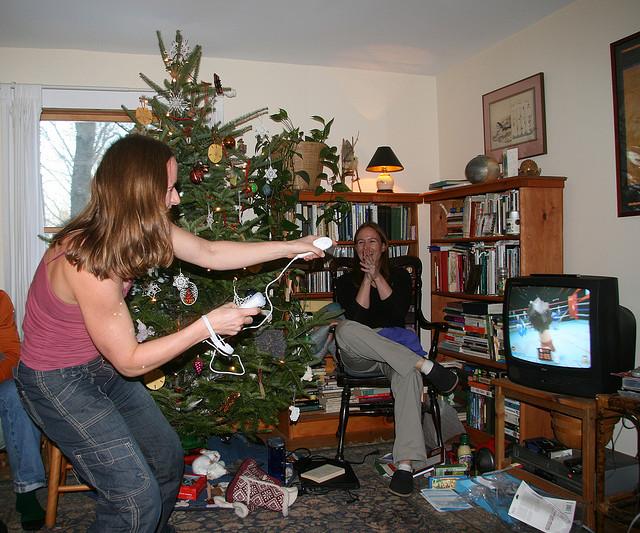What kind of tree is in the room?
Write a very short answer. Christmas. Is the lady playing a game?
Short answer required. Yes. Do they have a small TV?
Short answer required. Yes. What holiday season is it?
Keep it brief. Christmas. What game are the kids playing?
Answer briefly. Wii. What color hair do the women have?
Give a very brief answer. Brown. 